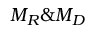Convert formula to latex. <formula><loc_0><loc_0><loc_500><loc_500>M _ { R } \& M _ { D }</formula> 